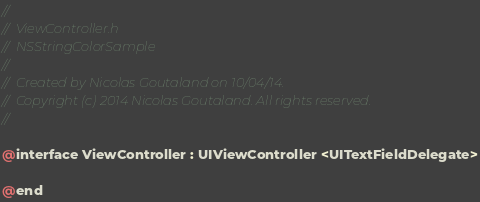<code> <loc_0><loc_0><loc_500><loc_500><_C_>//
//  ViewController.h
//  NSStringColorSample
//
//  Created by Nicolas Goutaland on 10/04/14.
//  Copyright (c) 2014 Nicolas Goutaland. All rights reserved.
//

@interface ViewController : UIViewController <UITextFieldDelegate>

@end
</code> 